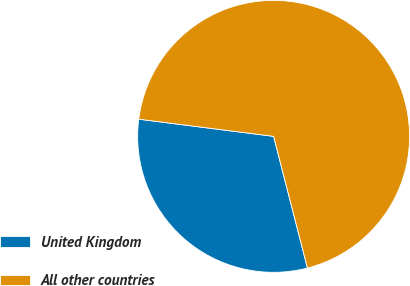<chart> <loc_0><loc_0><loc_500><loc_500><pie_chart><fcel>United Kingdom<fcel>All other countries<nl><fcel>31.02%<fcel>68.98%<nl></chart> 